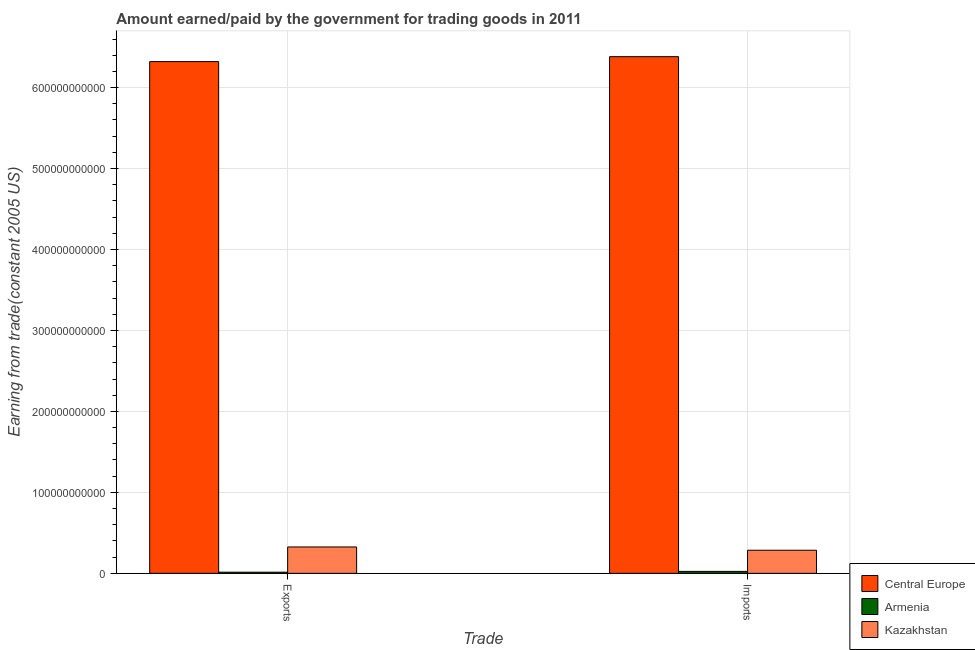How many different coloured bars are there?
Offer a very short reply. 3. How many groups of bars are there?
Offer a very short reply. 2. Are the number of bars per tick equal to the number of legend labels?
Keep it short and to the point. Yes. What is the label of the 1st group of bars from the left?
Your answer should be very brief. Exports. What is the amount paid for imports in Armenia?
Your answer should be very brief. 2.40e+09. Across all countries, what is the maximum amount paid for imports?
Your answer should be very brief. 6.38e+11. Across all countries, what is the minimum amount earned from exports?
Give a very brief answer. 1.43e+09. In which country was the amount earned from exports maximum?
Your answer should be very brief. Central Europe. In which country was the amount paid for imports minimum?
Provide a short and direct response. Armenia. What is the total amount earned from exports in the graph?
Provide a short and direct response. 6.66e+11. What is the difference between the amount earned from exports in Kazakhstan and that in Central Europe?
Ensure brevity in your answer.  -6.00e+11. What is the difference between the amount paid for imports in Armenia and the amount earned from exports in Central Europe?
Provide a short and direct response. -6.30e+11. What is the average amount paid for imports per country?
Your response must be concise. 2.23e+11. What is the difference between the amount paid for imports and amount earned from exports in Central Europe?
Offer a very short reply. 6.10e+09. In how many countries, is the amount paid for imports greater than 280000000000 US$?
Ensure brevity in your answer.  1. What is the ratio of the amount paid for imports in Kazakhstan to that in Central Europe?
Your answer should be very brief. 0.04. What does the 3rd bar from the left in Exports represents?
Provide a succinct answer. Kazakhstan. What does the 1st bar from the right in Imports represents?
Your response must be concise. Kazakhstan. How many bars are there?
Your answer should be compact. 6. Are all the bars in the graph horizontal?
Your answer should be very brief. No. How many countries are there in the graph?
Your response must be concise. 3. What is the difference between two consecutive major ticks on the Y-axis?
Your answer should be compact. 1.00e+11. Does the graph contain any zero values?
Make the answer very short. No. Does the graph contain grids?
Your answer should be very brief. Yes. How many legend labels are there?
Your answer should be very brief. 3. What is the title of the graph?
Your response must be concise. Amount earned/paid by the government for trading goods in 2011. Does "Northern Mariana Islands" appear as one of the legend labels in the graph?
Your answer should be very brief. No. What is the label or title of the X-axis?
Make the answer very short. Trade. What is the label or title of the Y-axis?
Your answer should be very brief. Earning from trade(constant 2005 US). What is the Earning from trade(constant 2005 US) of Central Europe in Exports?
Provide a succinct answer. 6.32e+11. What is the Earning from trade(constant 2005 US) of Armenia in Exports?
Provide a short and direct response. 1.43e+09. What is the Earning from trade(constant 2005 US) of Kazakhstan in Exports?
Ensure brevity in your answer.  3.26e+1. What is the Earning from trade(constant 2005 US) in Central Europe in Imports?
Make the answer very short. 6.38e+11. What is the Earning from trade(constant 2005 US) of Armenia in Imports?
Offer a very short reply. 2.40e+09. What is the Earning from trade(constant 2005 US) of Kazakhstan in Imports?
Provide a succinct answer. 2.85e+1. Across all Trade, what is the maximum Earning from trade(constant 2005 US) of Central Europe?
Give a very brief answer. 6.38e+11. Across all Trade, what is the maximum Earning from trade(constant 2005 US) in Armenia?
Your response must be concise. 2.40e+09. Across all Trade, what is the maximum Earning from trade(constant 2005 US) of Kazakhstan?
Provide a short and direct response. 3.26e+1. Across all Trade, what is the minimum Earning from trade(constant 2005 US) in Central Europe?
Keep it short and to the point. 6.32e+11. Across all Trade, what is the minimum Earning from trade(constant 2005 US) in Armenia?
Offer a very short reply. 1.43e+09. Across all Trade, what is the minimum Earning from trade(constant 2005 US) in Kazakhstan?
Make the answer very short. 2.85e+1. What is the total Earning from trade(constant 2005 US) of Central Europe in the graph?
Your answer should be very brief. 1.27e+12. What is the total Earning from trade(constant 2005 US) in Armenia in the graph?
Make the answer very short. 3.82e+09. What is the total Earning from trade(constant 2005 US) in Kazakhstan in the graph?
Keep it short and to the point. 6.11e+1. What is the difference between the Earning from trade(constant 2005 US) in Central Europe in Exports and that in Imports?
Ensure brevity in your answer.  -6.10e+09. What is the difference between the Earning from trade(constant 2005 US) in Armenia in Exports and that in Imports?
Your answer should be very brief. -9.70e+08. What is the difference between the Earning from trade(constant 2005 US) in Kazakhstan in Exports and that in Imports?
Your response must be concise. 4.05e+09. What is the difference between the Earning from trade(constant 2005 US) of Central Europe in Exports and the Earning from trade(constant 2005 US) of Armenia in Imports?
Provide a short and direct response. 6.30e+11. What is the difference between the Earning from trade(constant 2005 US) in Central Europe in Exports and the Earning from trade(constant 2005 US) in Kazakhstan in Imports?
Your response must be concise. 6.04e+11. What is the difference between the Earning from trade(constant 2005 US) of Armenia in Exports and the Earning from trade(constant 2005 US) of Kazakhstan in Imports?
Make the answer very short. -2.71e+1. What is the average Earning from trade(constant 2005 US) of Central Europe per Trade?
Ensure brevity in your answer.  6.35e+11. What is the average Earning from trade(constant 2005 US) of Armenia per Trade?
Your response must be concise. 1.91e+09. What is the average Earning from trade(constant 2005 US) of Kazakhstan per Trade?
Your answer should be compact. 3.06e+1. What is the difference between the Earning from trade(constant 2005 US) of Central Europe and Earning from trade(constant 2005 US) of Armenia in Exports?
Keep it short and to the point. 6.31e+11. What is the difference between the Earning from trade(constant 2005 US) of Central Europe and Earning from trade(constant 2005 US) of Kazakhstan in Exports?
Make the answer very short. 6.00e+11. What is the difference between the Earning from trade(constant 2005 US) of Armenia and Earning from trade(constant 2005 US) of Kazakhstan in Exports?
Ensure brevity in your answer.  -3.12e+1. What is the difference between the Earning from trade(constant 2005 US) of Central Europe and Earning from trade(constant 2005 US) of Armenia in Imports?
Provide a succinct answer. 6.36e+11. What is the difference between the Earning from trade(constant 2005 US) of Central Europe and Earning from trade(constant 2005 US) of Kazakhstan in Imports?
Ensure brevity in your answer.  6.10e+11. What is the difference between the Earning from trade(constant 2005 US) of Armenia and Earning from trade(constant 2005 US) of Kazakhstan in Imports?
Ensure brevity in your answer.  -2.61e+1. What is the ratio of the Earning from trade(constant 2005 US) of Armenia in Exports to that in Imports?
Provide a short and direct response. 0.6. What is the ratio of the Earning from trade(constant 2005 US) of Kazakhstan in Exports to that in Imports?
Give a very brief answer. 1.14. What is the difference between the highest and the second highest Earning from trade(constant 2005 US) of Central Europe?
Your answer should be compact. 6.10e+09. What is the difference between the highest and the second highest Earning from trade(constant 2005 US) in Armenia?
Ensure brevity in your answer.  9.70e+08. What is the difference between the highest and the second highest Earning from trade(constant 2005 US) of Kazakhstan?
Provide a succinct answer. 4.05e+09. What is the difference between the highest and the lowest Earning from trade(constant 2005 US) of Central Europe?
Provide a short and direct response. 6.10e+09. What is the difference between the highest and the lowest Earning from trade(constant 2005 US) of Armenia?
Offer a terse response. 9.70e+08. What is the difference between the highest and the lowest Earning from trade(constant 2005 US) in Kazakhstan?
Your answer should be very brief. 4.05e+09. 